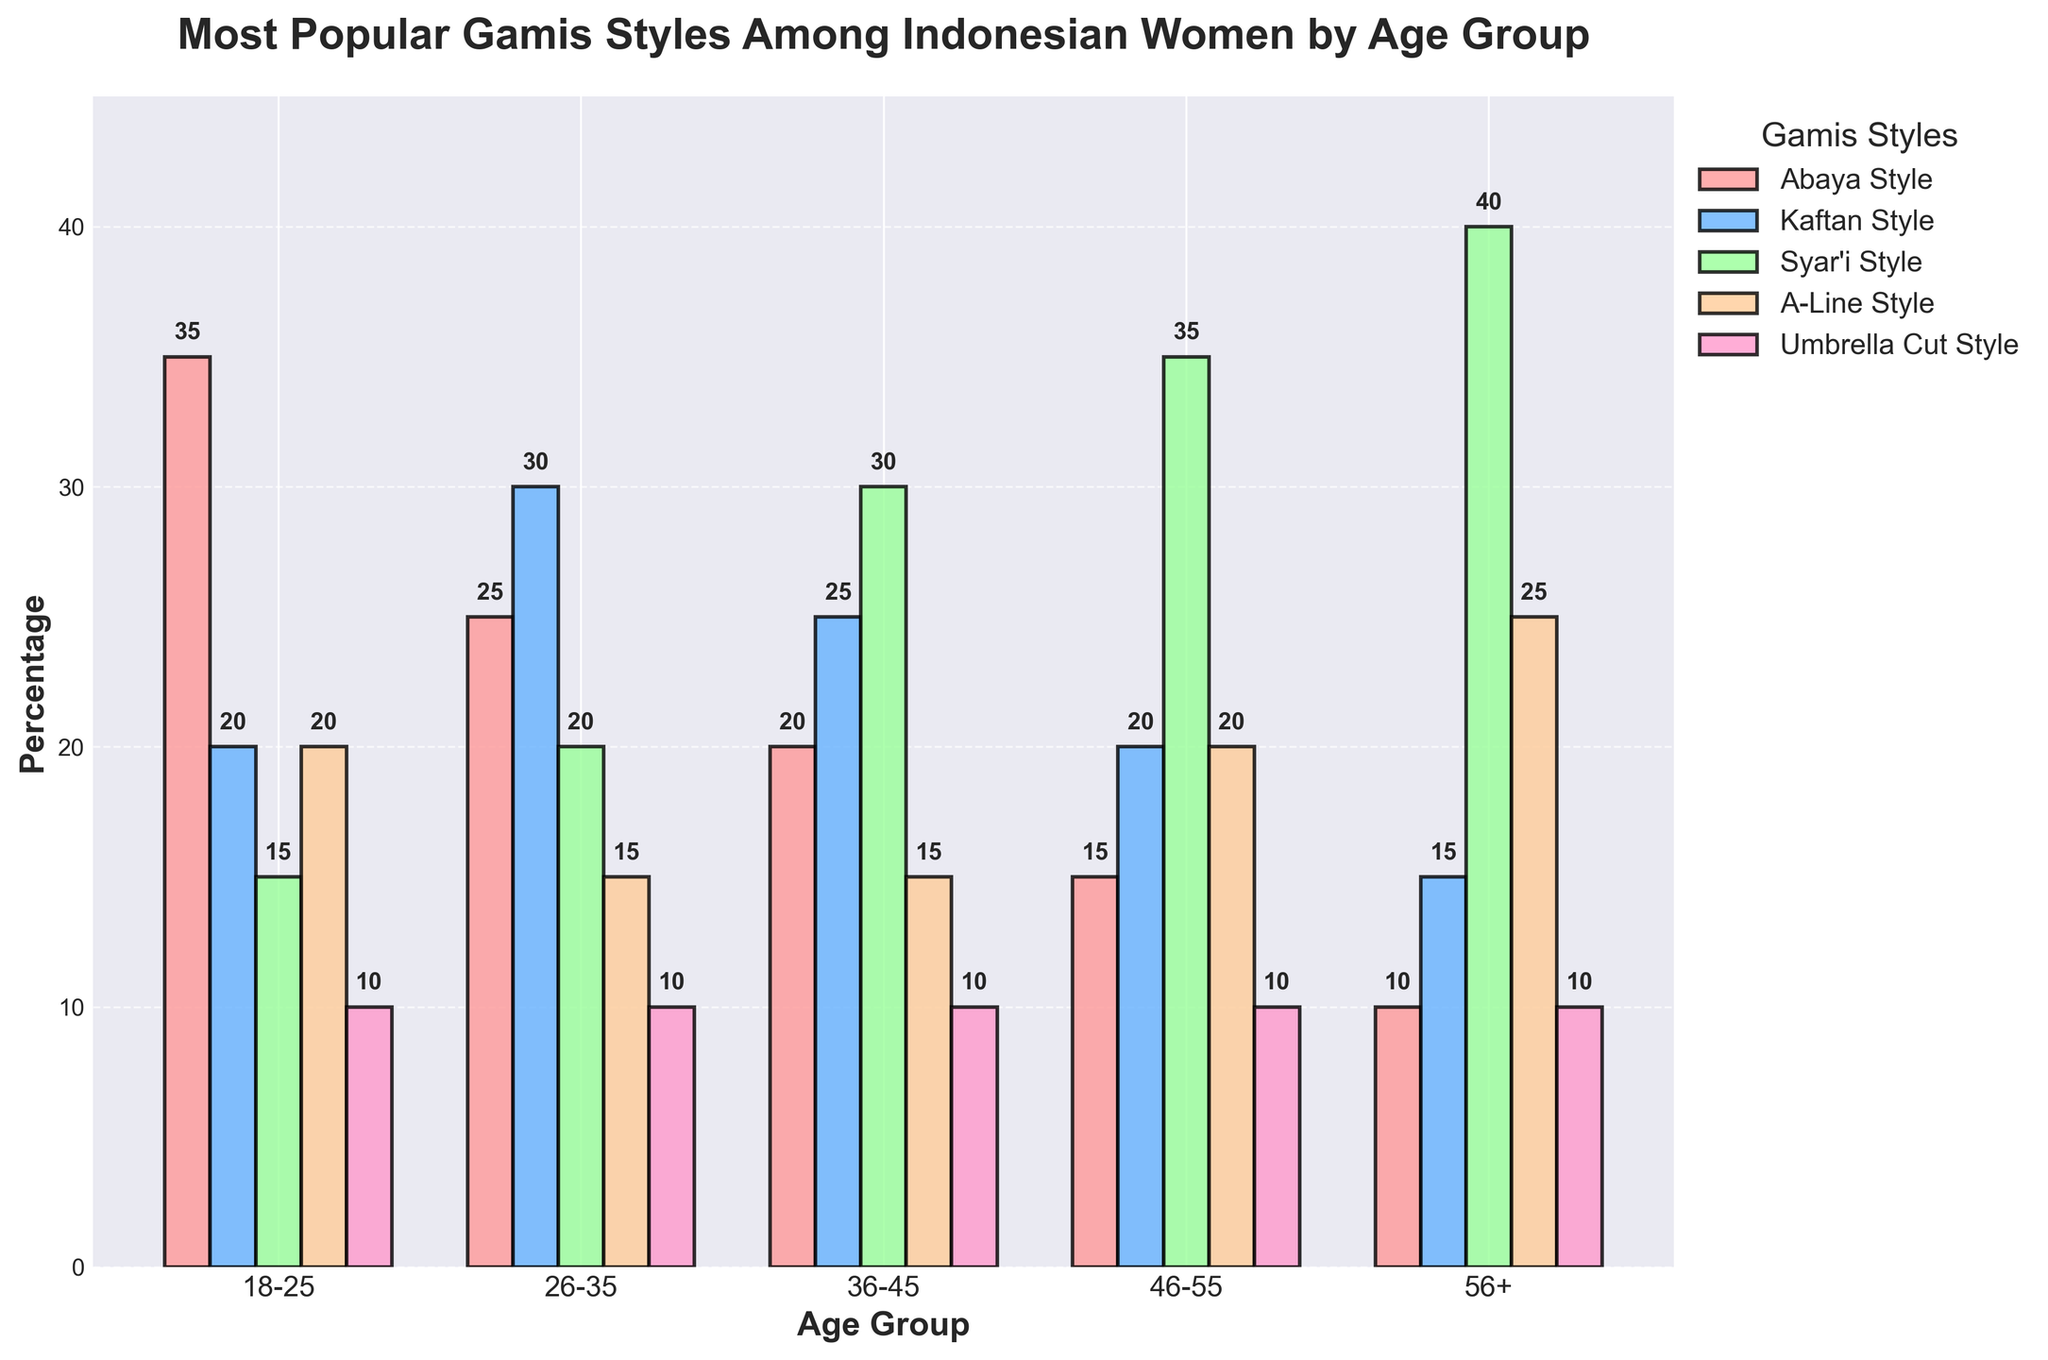Which age group prefers Syar'i Style the most? The figure shows that the age group with the highest percentage for Syar'i Style is the 56+ age group, where it reaches 40%.
Answer: 56+ Compare the popularity of Abaya Style among women aged 18-25 and 26-35. The bar corresponding to Abaya Style for both age groups can be compared. For the 18-25 age group, the percentage is 35%, while for the 26-35 age group, it is 25%.
Answer: 18-25 Which gamis style is least popular among women aged 46-55? Analyzing the bar heights for the 46-55 age group, Umbrella Cut Style has the shortest bar at 10%.
Answer: Umbrella Cut Style How does the popularity of A-Line Style differ between women aged 18-25 and women aged 56+? The A-Line Style is at 20% for the 18-25 age group and at 25% for the 56+ age group, showing an increase of 5%.
Answer: 25% (56+), 20% (18-25) What is the average popularity of Kaftan Style across all age groups? Summing the percentages for Kaftan Style across all groups gives 20 + 30 + 25 + 20 + 15 = 110. Dividing by 5 age groups, the average is 110/5 = 22%.
Answer: 22% Which age group has the least variation in popularity among the different styles? Evaluating the range in percentages for each age group, the 18-25 age group has the smallest difference (35% - 10% = 25%).
Answer: 18-25 Are there any age groups where the most popular style has a percentage greater than 35%? Reviewing the figure, Syar'i Style for the 56+ age group is the only one exceeding 35%, reaching 40%.
Answer: Yes, 56+ Between the age groups 36-45 and 46-55, which age group's most popular gamis style has a higher percentage? For the 36-45 age group, Syar'i Style is at 30%. For the 46-55 age group, Syar'i Style is at 35%. The 46-55 age group has the higher percentage.
Answer: 46-55 Which color represents the Kaftan Style in the figure? According to the legend, the Kaftan Style is represented by a blue bar color in the figure.
Answer: Blue Summarize the trend for Umbrella Cut Style across the age groups. Analyzing the bar heights for Umbrella Cut Style, it starts at 10% for 18-25, remains at 10% for 26-35, 36-45, and 46-55, and increases slightly to 10% for 56+. There is no significant change or trend.
Answer: No significant trend 